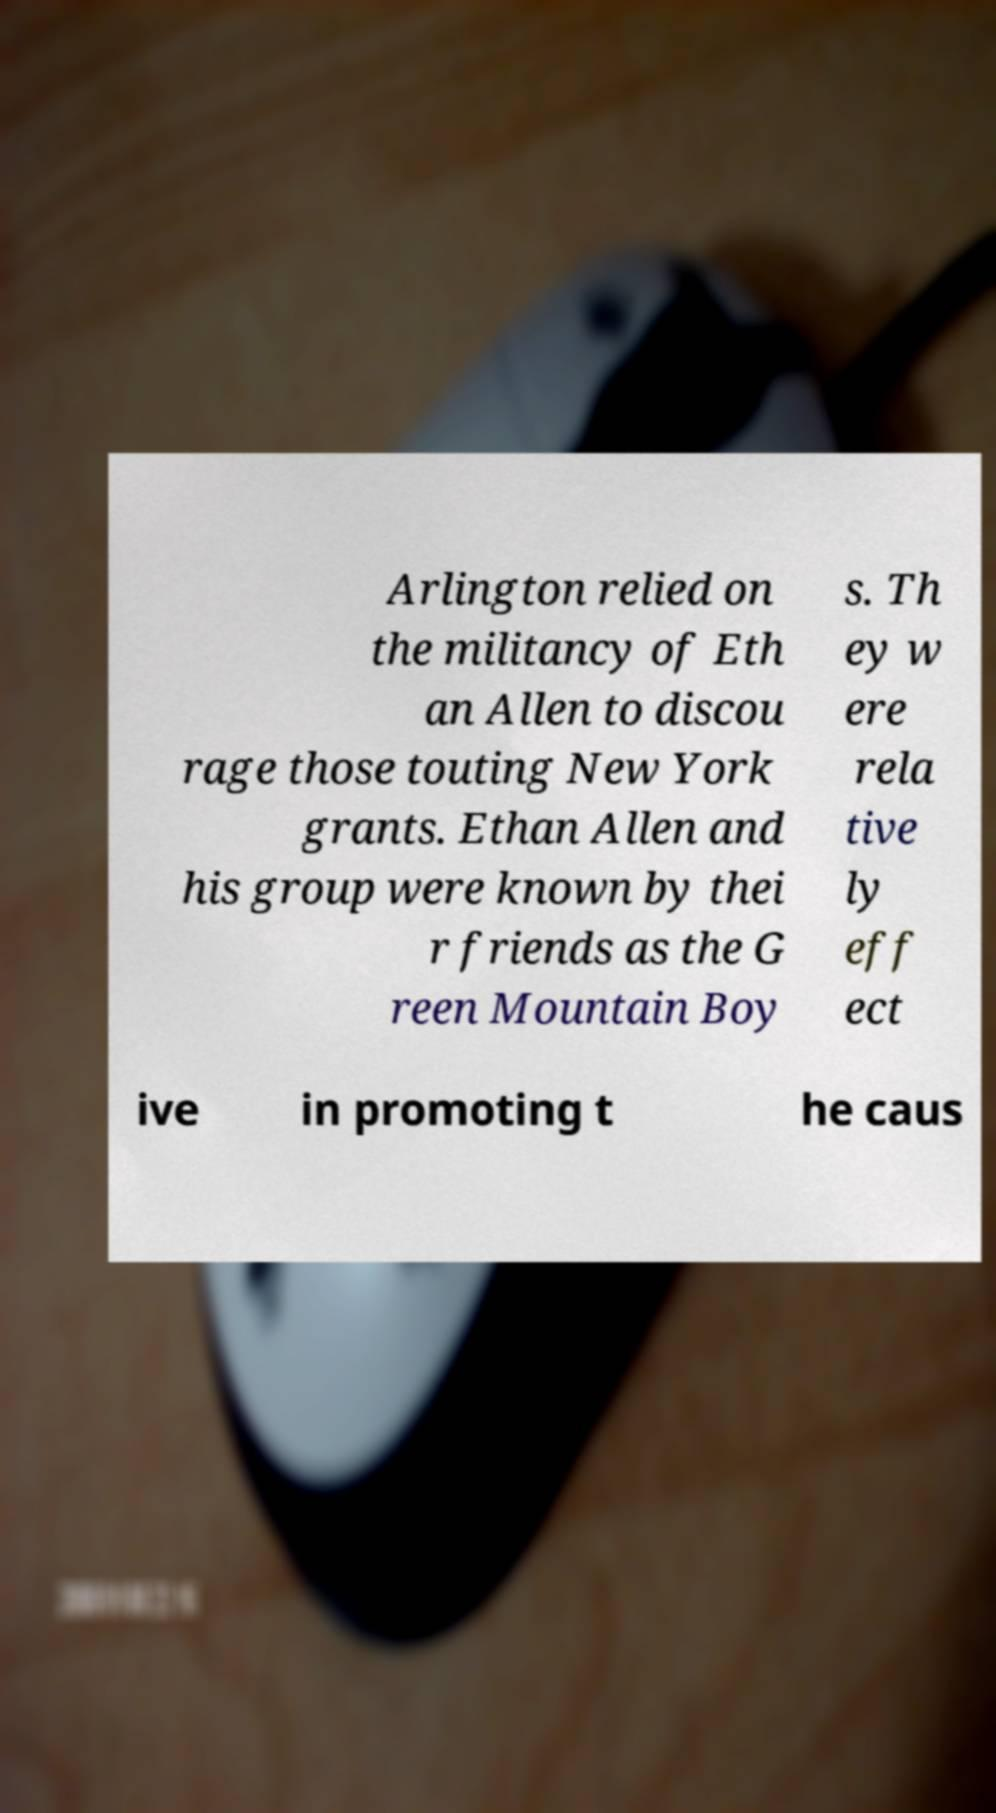Please read and relay the text visible in this image. What does it say? Arlington relied on the militancy of Eth an Allen to discou rage those touting New York grants. Ethan Allen and his group were known by thei r friends as the G reen Mountain Boy s. Th ey w ere rela tive ly eff ect ive in promoting t he caus 